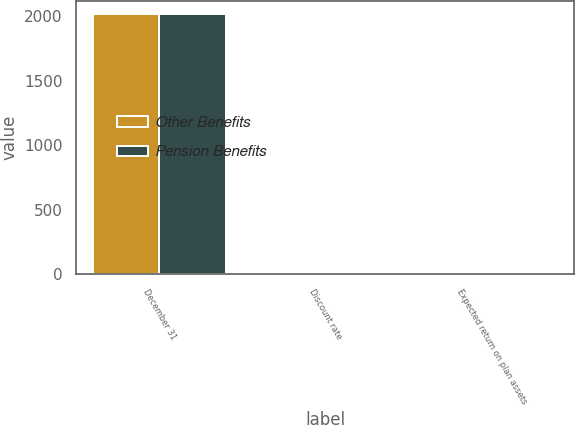Convert chart to OTSL. <chart><loc_0><loc_0><loc_500><loc_500><stacked_bar_chart><ecel><fcel>December 31<fcel>Discount rate<fcel>Expected return on plan assets<nl><fcel>Other Benefits<fcel>2016<fcel>4.86<fcel>7.14<nl><fcel>Pension Benefits<fcel>2016<fcel>4.39<fcel>7.25<nl></chart> 